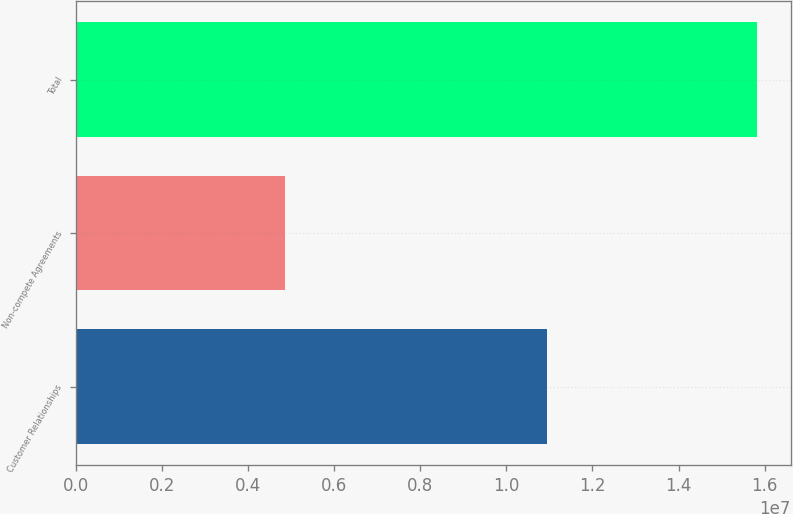Convert chart to OTSL. <chart><loc_0><loc_0><loc_500><loc_500><bar_chart><fcel>Customer Relationships<fcel>Non-compete Agreements<fcel>Total<nl><fcel>1.0954e+07<fcel>4.868e+06<fcel>1.5822e+07<nl></chart> 